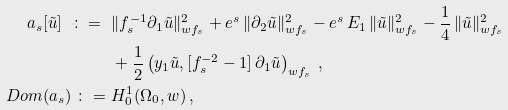Convert formula to latex. <formula><loc_0><loc_0><loc_500><loc_500>a _ { s } [ \tilde { u } ] \ \colon = \ & \| f _ { s } ^ { - 1 } \partial _ { 1 } \tilde { u } \| _ { w f _ { s } } ^ { 2 } + e ^ { s } \, \| \partial _ { 2 } \tilde { u } \| _ { w f _ { s } } ^ { 2 } - e ^ { s } \, E _ { 1 } \, \| \tilde { u } \| _ { w f _ { s } } ^ { 2 } - \frac { 1 } { 4 } \, \| \tilde { u } \| _ { w f _ { s } } ^ { 2 } \\ & + \frac { 1 } { 2 } \left ( y _ { 1 } \tilde { u } , [ f _ { s } ^ { - 2 } - 1 ] \, \partial _ { 1 } \tilde { u } \right ) _ { w f _ { s } } \, , \\ \ D o m ( a _ { s } ) \ \colon = \ & H _ { 0 } ^ { 1 } ( \Omega _ { 0 } , w ) \, ,</formula> 